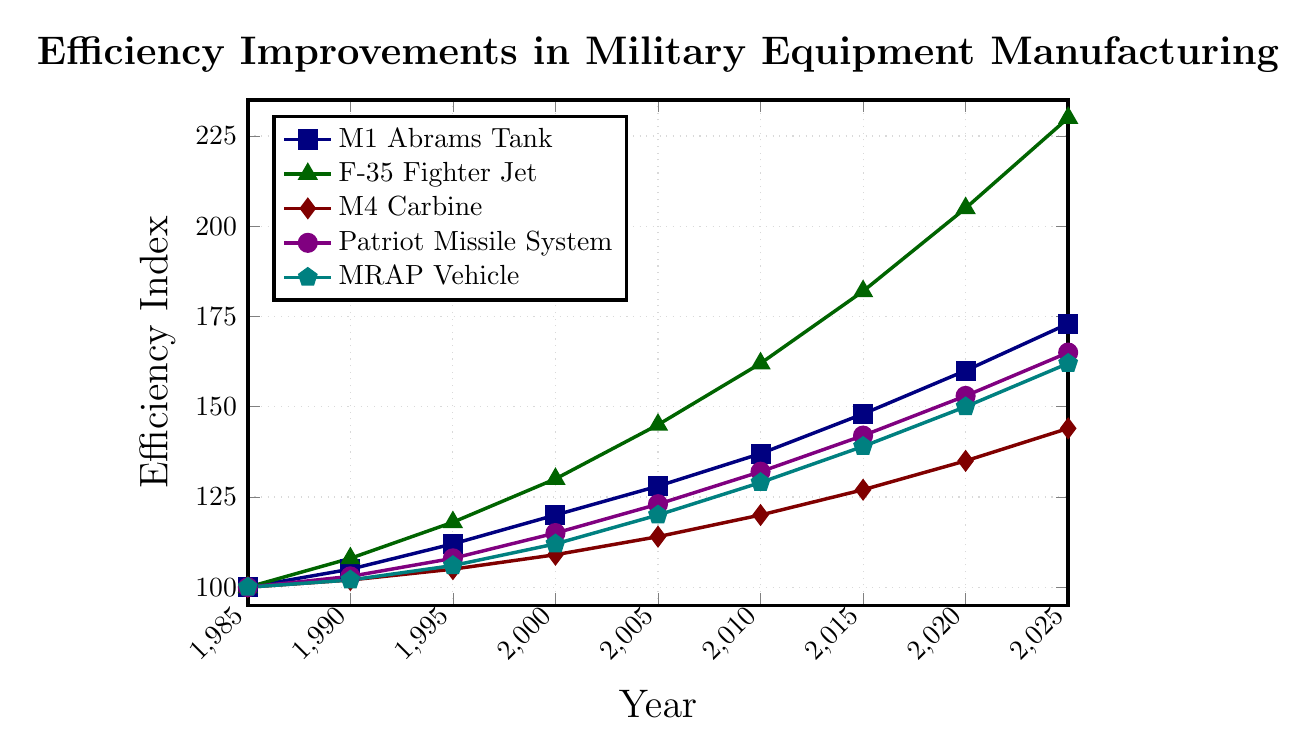What is the overall trend of the efficiency improvement in manufacturing the F-35 Fighter Jet from 1985 to 2025? The efficiency index of the F-35 Fighter Jet rises consistently from 100 in 1985 to 230 in 2025, suggesting a significant and continuous improvement in manufacturing efficiency over the years.
Answer: The efficiency improvement trend is significantly upward Which manufacturing process shows the least improvement in efficiency from 1985 to 2025? By comparing the efficiency indices of all equipment from 1985 to 2025, we see that the M4 Carbine increases from 100 to 144, which is the smallest increase relative to the others.
Answer: M4 Carbine Between which years did the M1 Abrams Tank see the highest rate of efficiency improvement? To determine this, we compare the increments between each consecutive period. The highest increment is between 2015 (148) and 2020 (160), resulting in an increase of 12 points.
Answer: Between 2015 and 2020 How does the efficiency improvement of the MRAP Vehicle compare to the M1 Abrams Tank in 2025? In 2025, the efficiency index for the MRAP Vehicle is 162 and for the M1 Abrams Tank is 173. Comparing these values directly shows the M1 Abrams Tank has a higher efficiency improvement.
Answer: M1 Abrams Tank is higher in 2025 What is the average efficiency index of the Patriot Missile System over the decades shown? Sum up the efficiency indices from 1985 to 2025 (100 + 103 + 108 + 115 + 123 + 132 + 142 + 153 + 165 = 1141) and divide by the number of data points (9), resulting in an average of about 126.78.
Answer: 126.78 What is the difference in the efficiency indices of the M4 Carbine and the Patriot Missile System in 2000? In 2000, the M4 Carbine has an efficiency index of 109 and the Patriot Missile System has 115. The difference is 115 - 109 = 6.
Answer: 6 